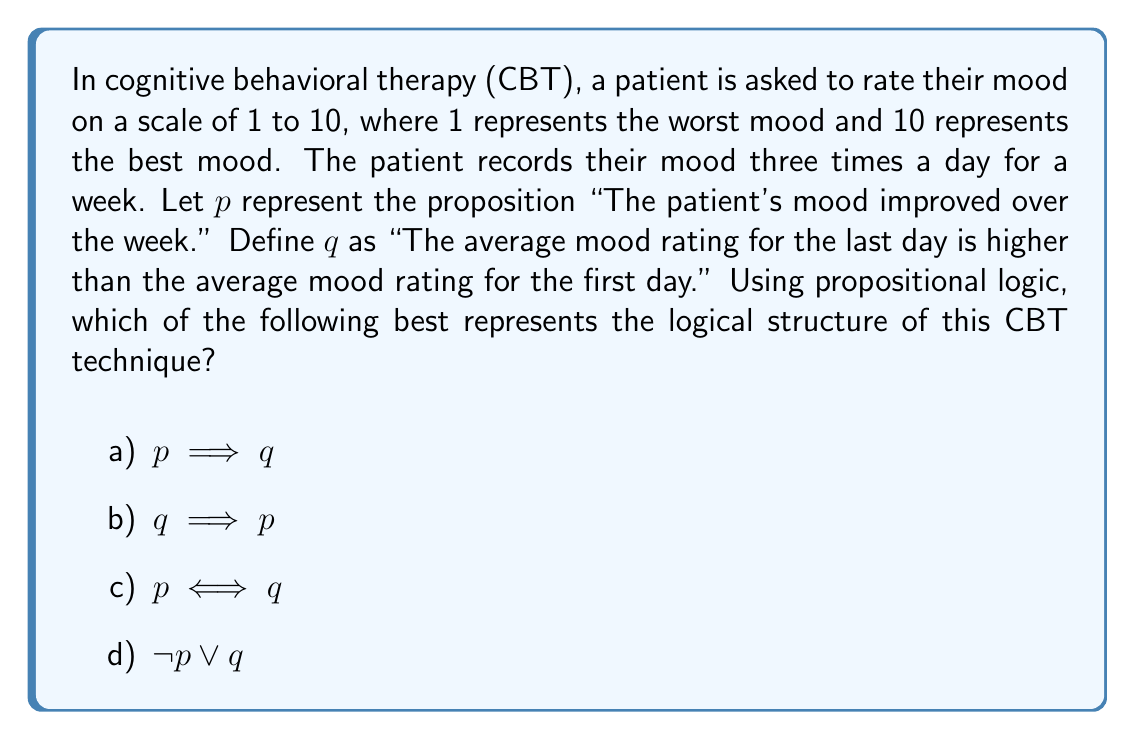Could you help me with this problem? To evaluate the logical structure of this cognitive behavioral therapy technique, we need to consider the relationship between the patient's mood improvement (p) and the comparison of average mood ratings (q).

1. First, let's consider $p \implies q$:
   This means "If the patient's mood improved over the week, then the average mood rating for the last day is higher than the first day."
   This is not necessarily true, as mood improvement could be subtle or inconsistent.

2. Now, let's examine $q \implies p$:
   This means "If the average mood rating for the last day is higher than the first day, then the patient's mood improved over the week."
   This is closer to the logical structure of the CBT technique, as a higher average on the last day generally indicates improvement.

3. For $p \iff q$:
   This means "The patient's mood improved over the week if and only if the average mood rating for the last day is higher than the first day."
   This is too strong, as it doesn't allow for other factors or interpretations of mood improvement.

4. Finally, $\neg p \lor q$:
   This is logically equivalent to $p \implies q$, which we've already determined is not the best representation.

The most appropriate logical structure is $q \implies p$, as it represents the inference made in CBT: observing a higher average mood rating on the last day compared to the first day implies an overall mood improvement. This aligns with the evidence-based approach of CBT, where observable data (mood ratings) are used to draw conclusions about the patient's progress.

It's important to note that in real-world therapy, this logical structure would be part of a broader assessment and not the sole determinant of mood improvement. As an author and mental health advocate dealing with bipolar disorder, you would likely appreciate the nuanced approach required in interpreting such data.
Answer: b) $q \implies p$ 